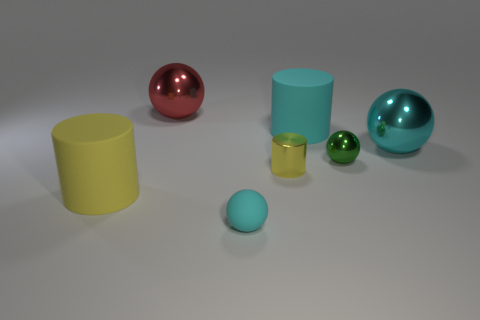Add 1 big cyan metal balls. How many objects exist? 8 Subtract all cylinders. How many objects are left? 4 Subtract 0 gray cylinders. How many objects are left? 7 Subtract all big cyan rubber things. Subtract all tiny gray shiny spheres. How many objects are left? 6 Add 5 tiny yellow cylinders. How many tiny yellow cylinders are left? 6 Add 2 tiny yellow metallic things. How many tiny yellow metallic things exist? 3 